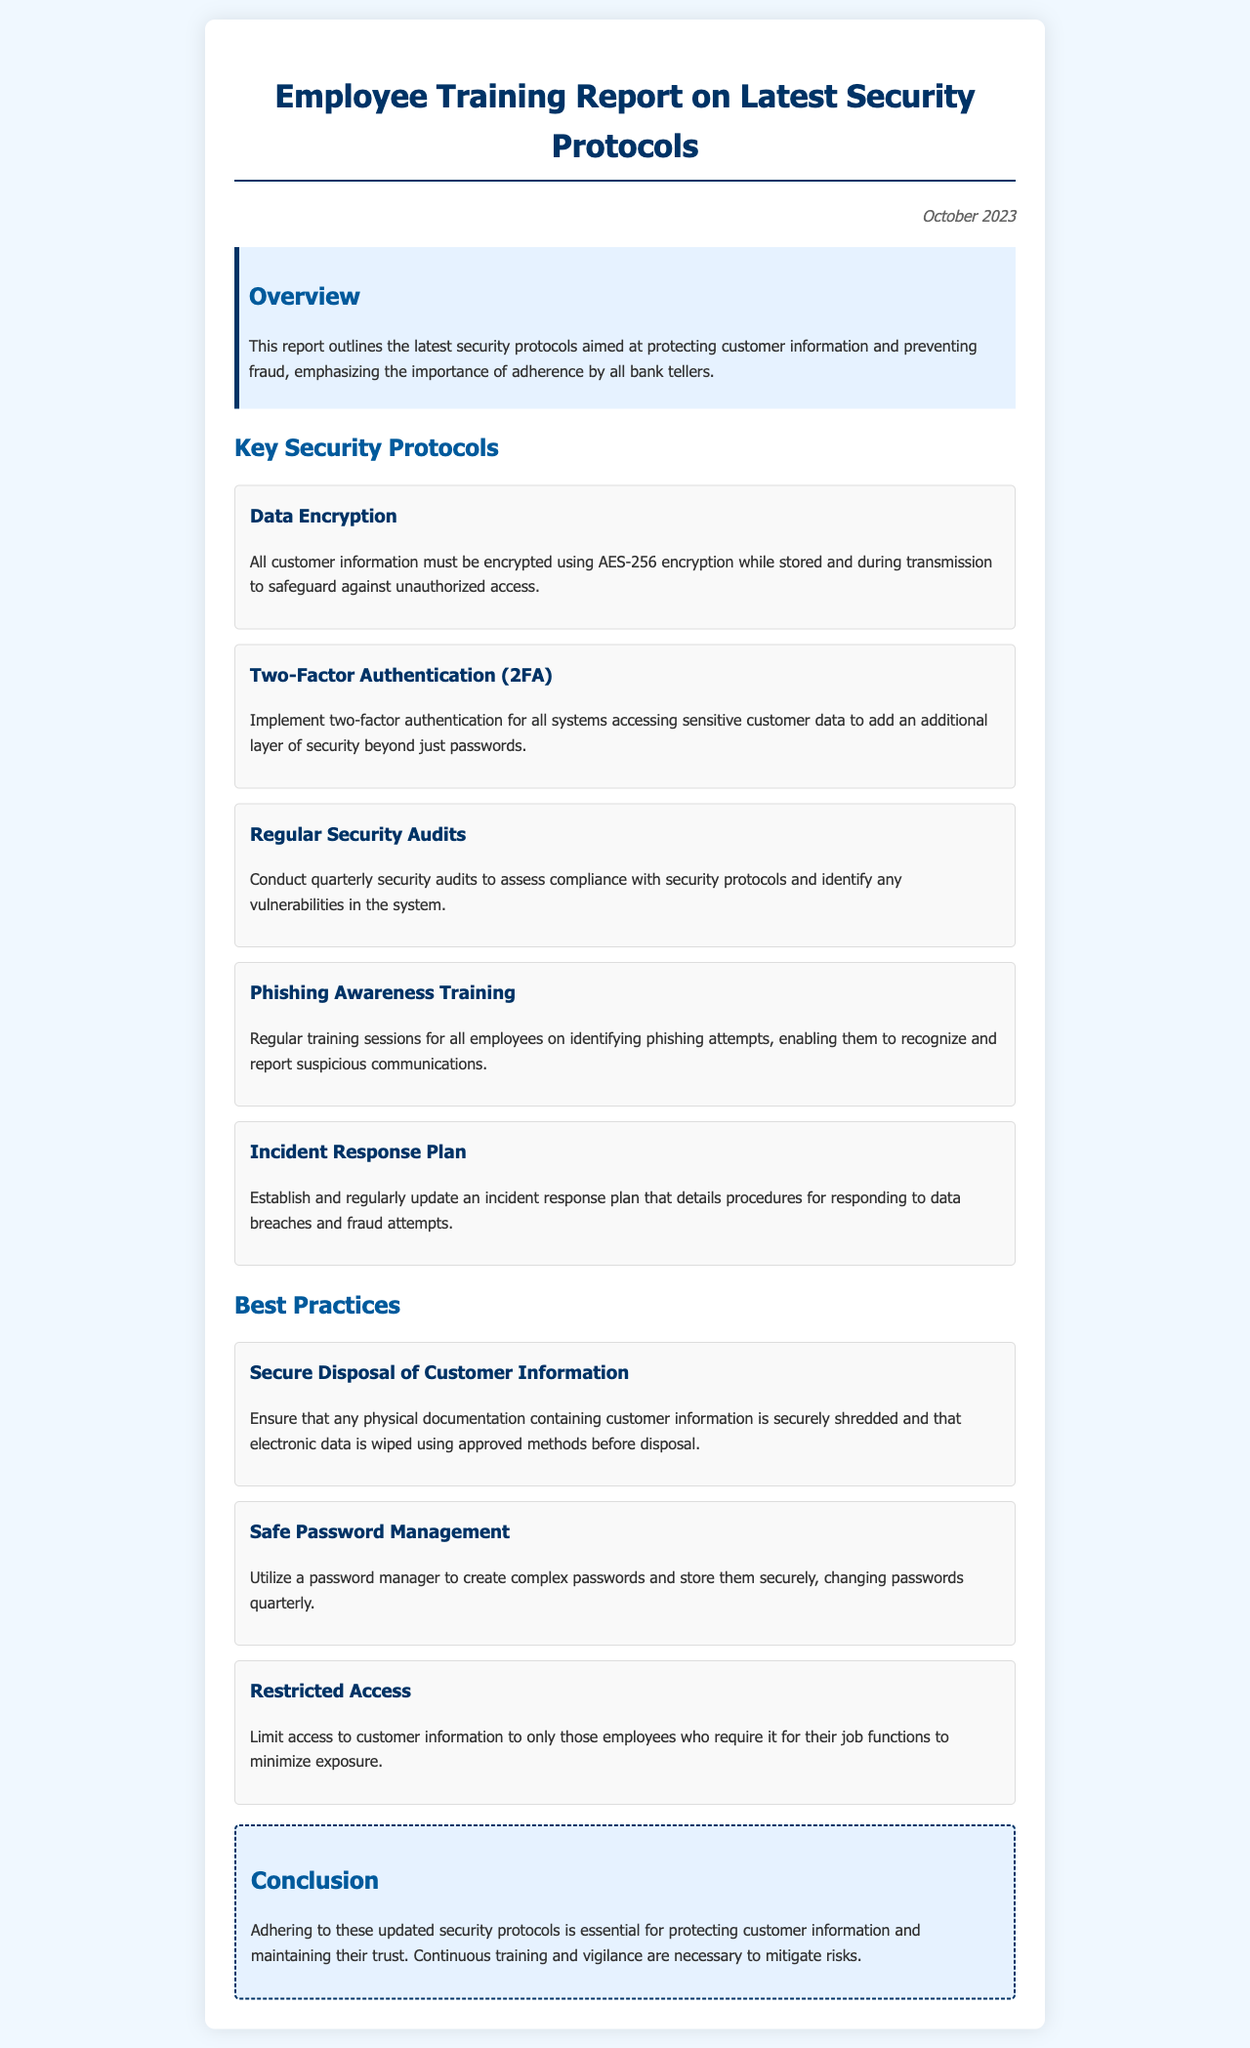what is the title of the report? The title is indicated prominently at the top of the document, summarizing the focus on employee training regarding security.
Answer: Employee Training Report on Latest Security Protocols when was the report published? The date is mentioned in the document, providing context for when the information is current.
Answer: October 2023 how many key security protocols are listed? The number of protocols can be counted under the section dedicated to key security protocols.
Answer: Five what encryption method is required for customer information? The document specifies the encryption method that must be used to protect customer data.
Answer: AES-256 what is the purpose of two-factor authentication? This question focuses on understanding the significance of two-factor authentication as mentioned in the report.
Answer: Additional layer of security how often should security audits be conducted? The report outlines a schedule for security audits to ensure compliance and security effectiveness.
Answer: Quarterly which best practice involves handling physical documentation? The document describes how to properly dispose of physical documents to maintain security.
Answer: Secure Disposal of Customer Information what is a key aspect of the incident response plan? This question seeks to understand what is essential regarding response procedures for breaches.
Answer: Regularly update what training is emphasized for employees? The report highlights a specific type of training aimed at helping employees recognize threats.
Answer: Phishing Awareness Training 